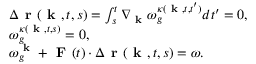Convert formula to latex. <formula><loc_0><loc_0><loc_500><loc_500>\begin{array} { r l } & { \Delta r ( k , t , s ) = \int _ { s } ^ { t } \nabla _ { k } \omega _ { g } ^ { \kappa ( k , t , t ^ { \prime } ) } d t ^ { \prime } = 0 , } \\ & { \omega _ { g } ^ { \kappa ( k , t , s ) } = 0 , } \\ & { \omega _ { g } ^ { k } + F ( t ) \cdot \Delta r ( k , t , s ) = \omega . } \end{array}</formula> 